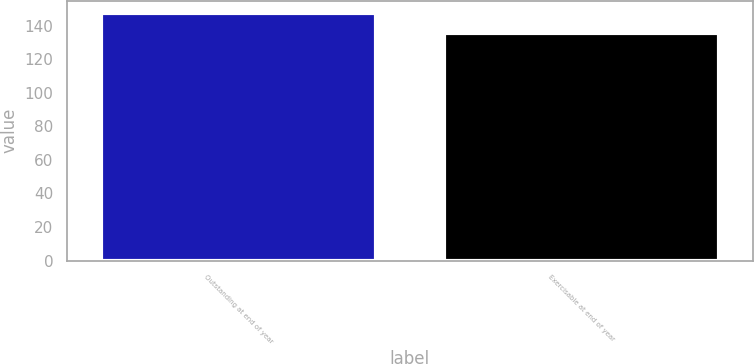<chart> <loc_0><loc_0><loc_500><loc_500><bar_chart><fcel>Outstanding at end of year<fcel>Exercisable at end of year<nl><fcel>147.41<fcel>135.42<nl></chart> 